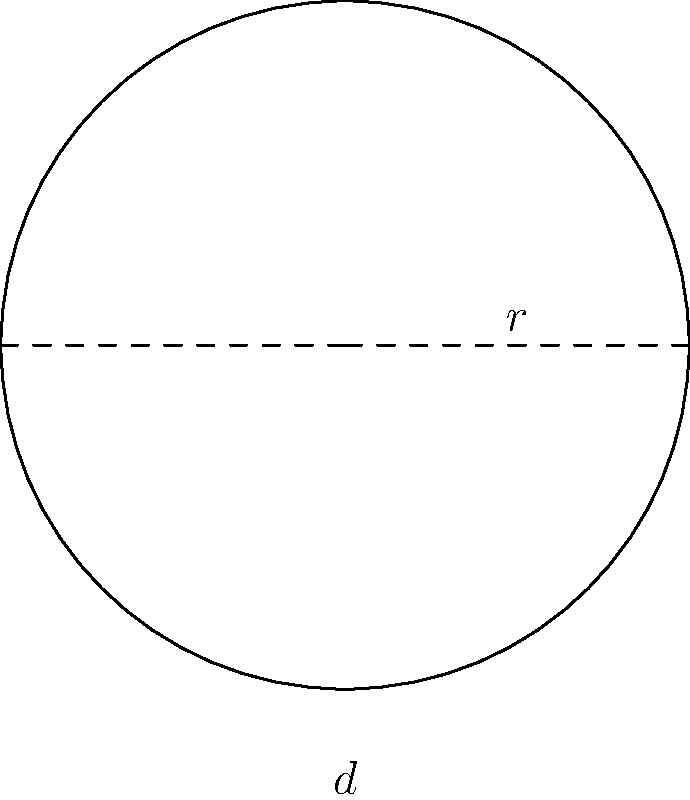Faustino, tu amigo de la infancia, te cuenta que está reparando una vieja bicicleta que encontró en el rancho de su abuelo en Tamaulipas. La rueda tiene un diámetro de 66 centímetros. ¿Cuál es la circunferencia de la rueda en centímetros? Usa $\pi = 3.14$ para tus cálculos. Para calcular la circunferencia de la rueda de bicicleta, seguiremos estos pasos:

1. Recordemos la fórmula para la circunferencia de un círculo:
   $C = \pi d$, donde $C$ es la circunferencia, $\pi$ es pi, y $d$ es el diámetro.

2. Tenemos el diámetro $d = 66$ cm y usaremos $\pi = 3.14$.

3. Sustituyamos estos valores en la fórmula:
   $C = \pi d = 3.14 \times 66$ cm

4. Realicemos la multiplicación:
   $C = 207.24$ cm

5. Redondeamos al centímetro más cercano:
   $C \approx 207$ cm

Por lo tanto, la circunferencia de la rueda de la bicicleta es aproximadamente 207 centímetros.
Answer: 207 cm 